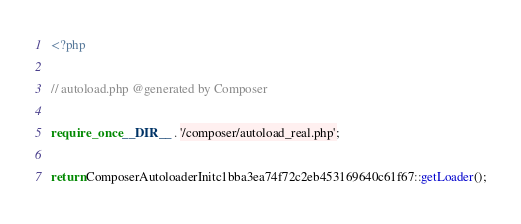<code> <loc_0><loc_0><loc_500><loc_500><_PHP_><?php

// autoload.php @generated by Composer

require_once __DIR__ . '/composer/autoload_real.php';

return ComposerAutoloaderInitc1bba3ea74f72c2eb453169640c61f67::getLoader();
</code> 